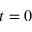Convert formula to latex. <formula><loc_0><loc_0><loc_500><loc_500>t = 0</formula> 